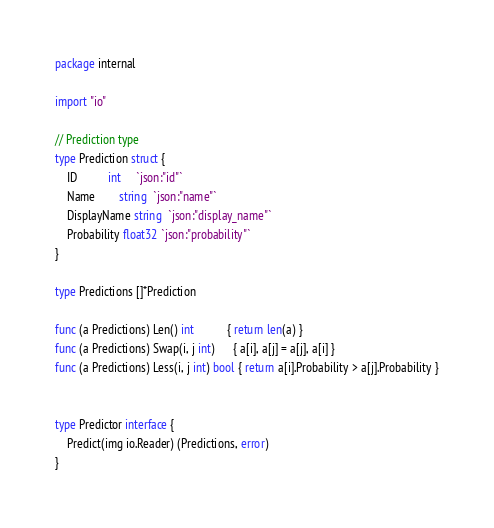<code> <loc_0><loc_0><loc_500><loc_500><_Go_>package internal

import "io"

// Prediction type
type Prediction struct {
	ID          int     `json:"id"`
	Name        string  `json:"name"`
	DisplayName string  `json:"display_name"`
	Probability float32 `json:"probability"`
}

type Predictions []*Prediction

func (a Predictions) Len() int           { return len(a) }
func (a Predictions) Swap(i, j int)      { a[i], a[j] = a[j], a[i] }
func (a Predictions) Less(i, j int) bool { return a[i].Probability > a[j].Probability }


type Predictor interface {
	Predict(img io.Reader) (Predictions, error)
}
</code> 